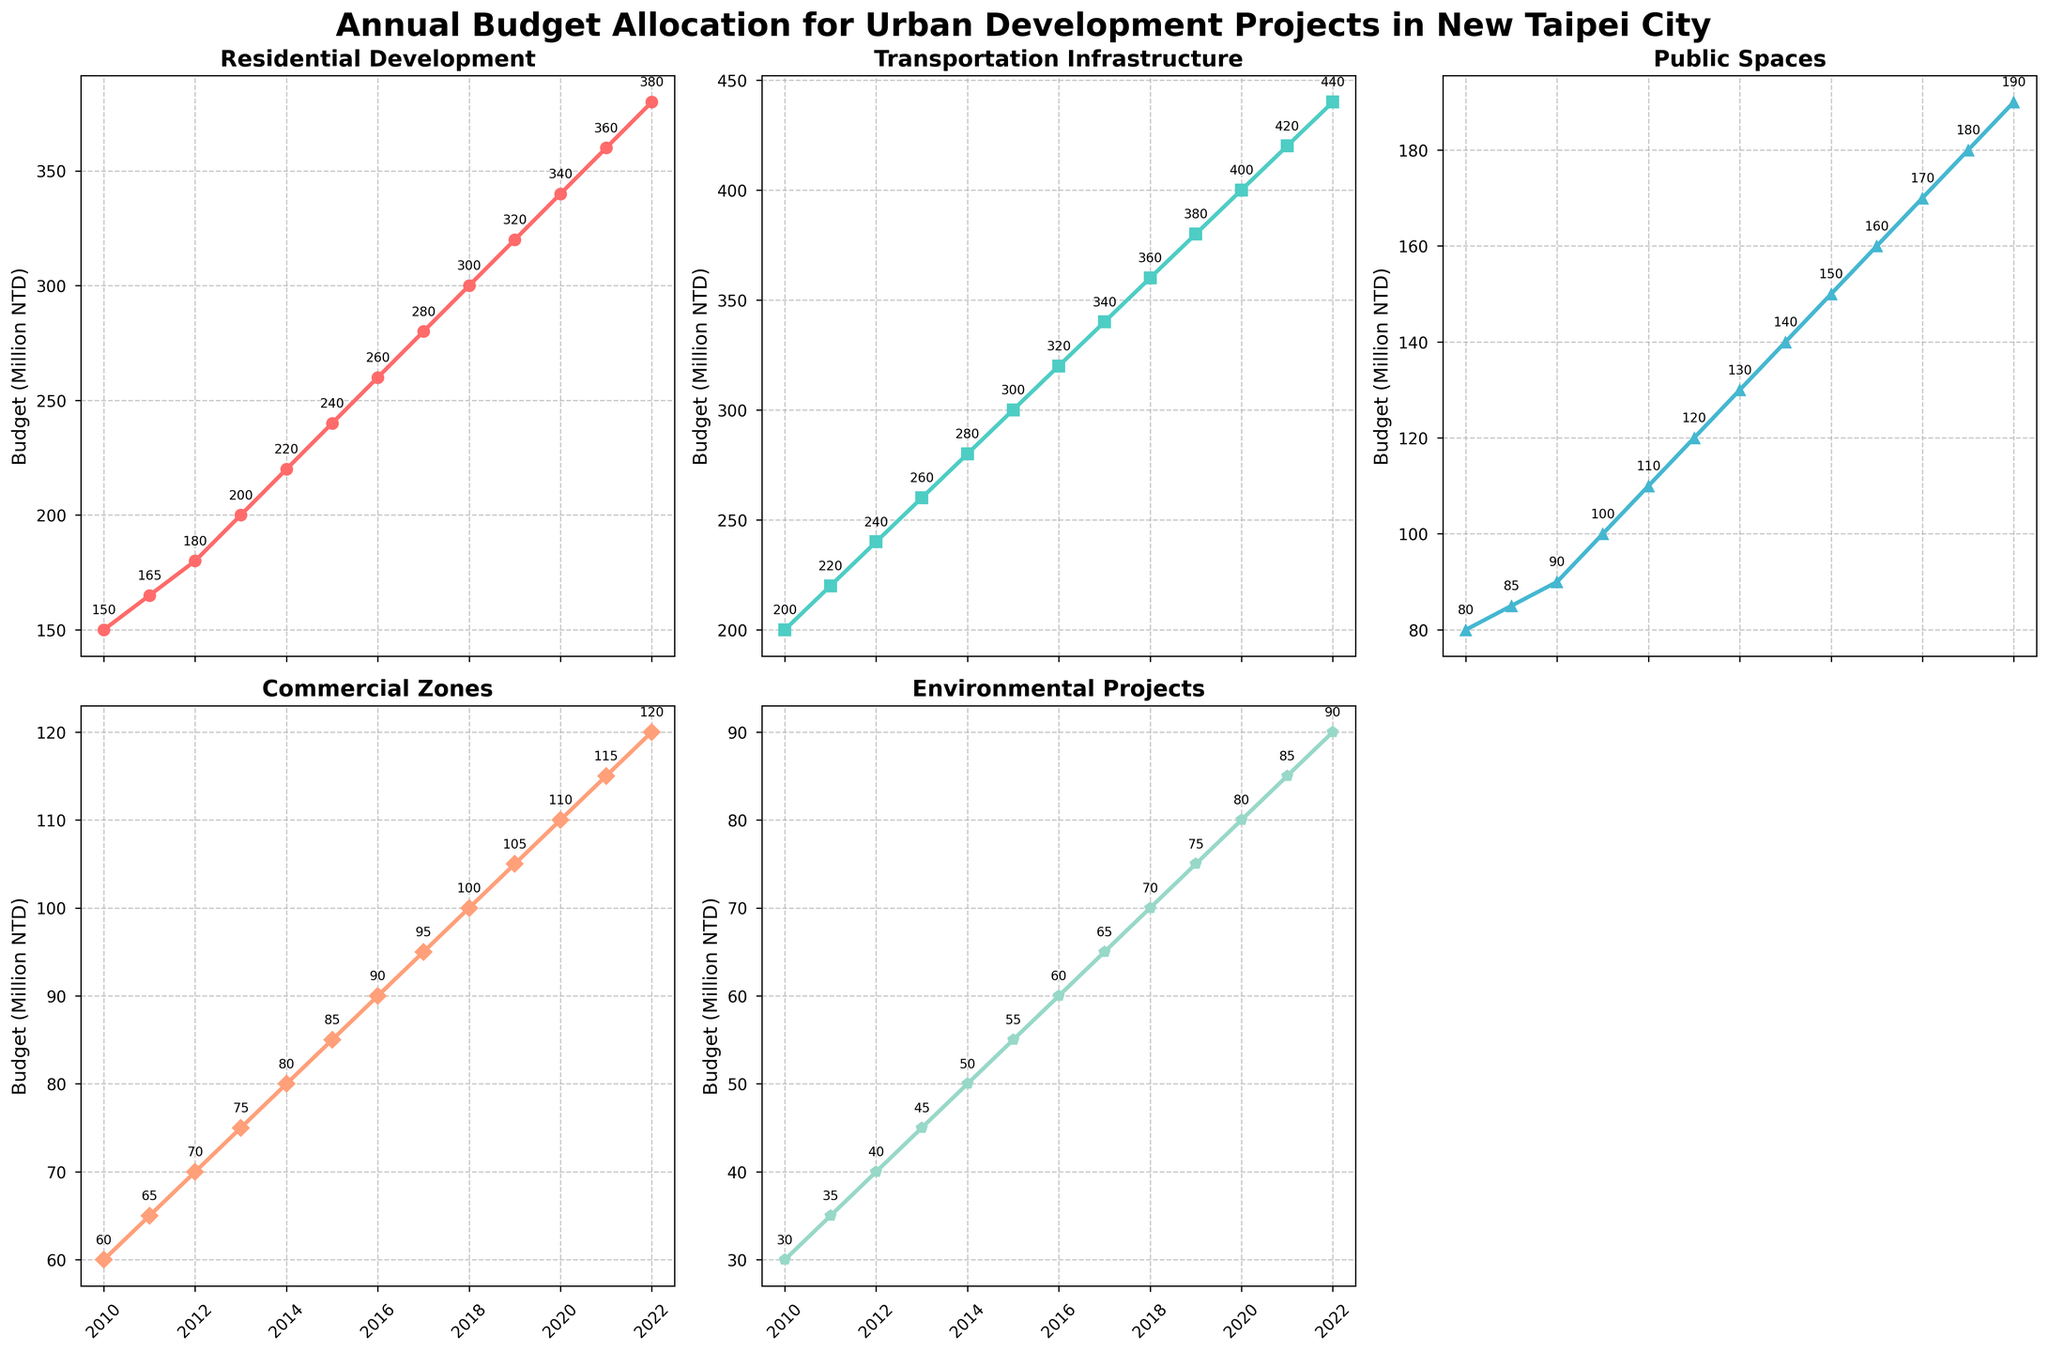What is the title of the figure? The title is displayed at the top of the figure, indicating the overall subject of the data shown in the subplots. The title reads "Annual Budget Allocation for Urban Development Projects in New Taipei City" as per the provided code.
Answer: Annual Budget Allocation for Urban Development Projects in New Taipei City What is the budget allocated for Transportation Infrastructure in 2015? From the subplot corresponding to Transportation Infrastructure, you can find the point for the year 2015 and read off the budget value annotated near the point. The value is 300 million NTD as per the data.
Answer: 300 million NTD How does the budget for Environmental Projects change from 2010 to 2022? Observe the subplot corresponding to Environmental Projects and note the budget values at 2010 and 2022. The budget increases from 30 million NTD in 2010 to 90 million NTD in 2022, showing a consistent upward trend.
Answer: Increased from 30 million NTD to 90 million NTD Between Residential Development and Public Spaces, which sector received more budget allocation over the years? Compare the subplots of Residential Development and Public Spaces. Residential Development consistently has higher budget values than Public Spaces across all years.
Answer: Residential Development What is the average annual budget allocated to Commercial Zones from 2010 to 2022? Add the annual budget values for Commercial Zones from 2010 to 2022 (60 + 65 + 70 + 75 + 80 + 85 + 90 + 95 + 100 + 105 + 110 + 115 + 120) and divide by the number of years (13). The sum is 1170, so the average is 1170/13 ≈ 90 million NTD.
Answer: Approximately 90 million NTD Which year saw the highest budget allocation for Public Spaces? Look at the subplot for Public Spaces and identify the year with the highest budget value. The highest value is 190 million NTD in 2022.
Answer: 2022 What was the total budget for all sectors combined in the year 2019? Add the budget values of all sectors for the year 2019 (320 + 380 + 160 + 105 + 75). The sum is 1040 million NTD.
Answer: 1040 million NTD Which sector saw the most significant budget increase from 2010 to 2022? Calculate the difference in budget for each sector between 2010 and 2022. Residential Development: 380-150=230, Transportation Infrastructure: 440-200=240, Public Spaces: 190-80=110, Commercial Zones: 120-60=60, Environmental Projects: 90-30=60. The largest increase is in Transportation Infrastructure with 240 million NTD.
Answer: Transportation Infrastructure How does the budget allocation trend for Commercial Zones compare from 2012 to 2016? Look at the line chart for Commercial Zones from 2012 to 2016 and describe the trend. The budget increases gradually from 70 million NTD in 2012 to 90 million NTD in 2016.
Answer: Gradual increase What is the budget allocation difference between 2015 and 2020 for Residential Development? Subtract the budget value of Residential Development in 2015 from that in 2020. The difference is 340 - 240 = 100 million NTD.
Answer: 100 million NTD 